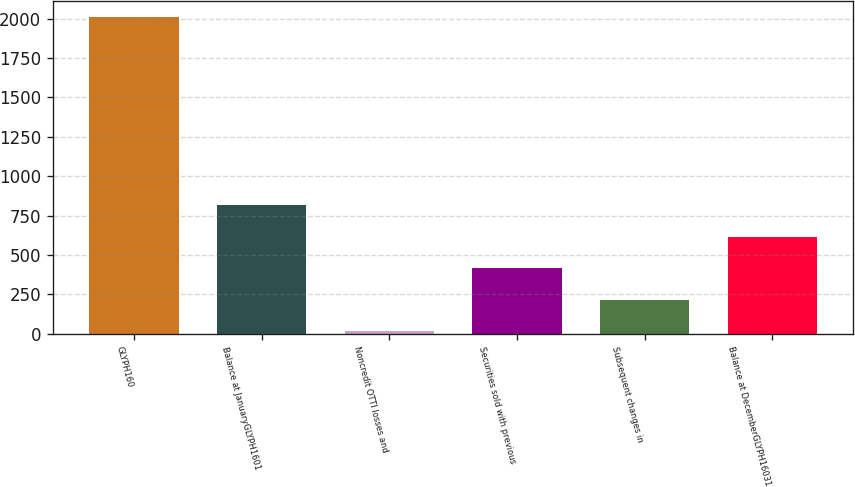Convert chart to OTSL. <chart><loc_0><loc_0><loc_500><loc_500><bar_chart><fcel>GLYPH160<fcel>Balance at JanuaryGLYPH1601<fcel>Noncredit OTTI losses and<fcel>Securities sold with previous<fcel>Subsequent changes in<fcel>Balance at DecemberGLYPH16031<nl><fcel>2014<fcel>815.8<fcel>17<fcel>416.4<fcel>216.7<fcel>616.1<nl></chart> 